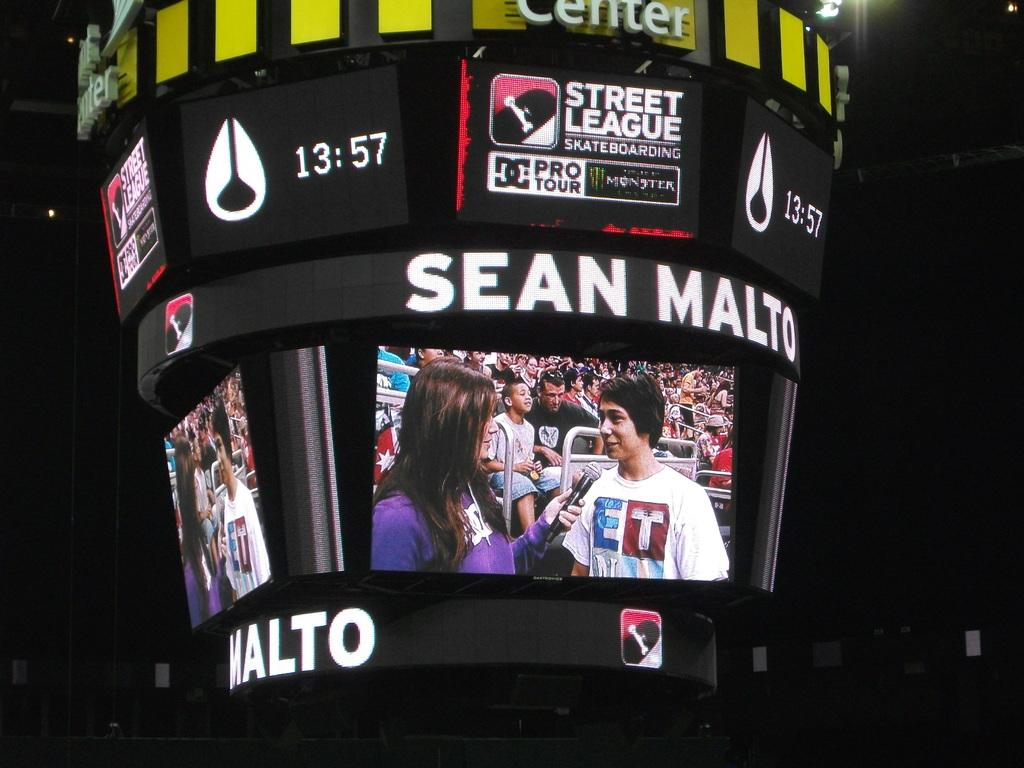<image>
Write a terse but informative summary of the picture. A jumbo tron showing Sean Malto being interviewed by a reporter. 